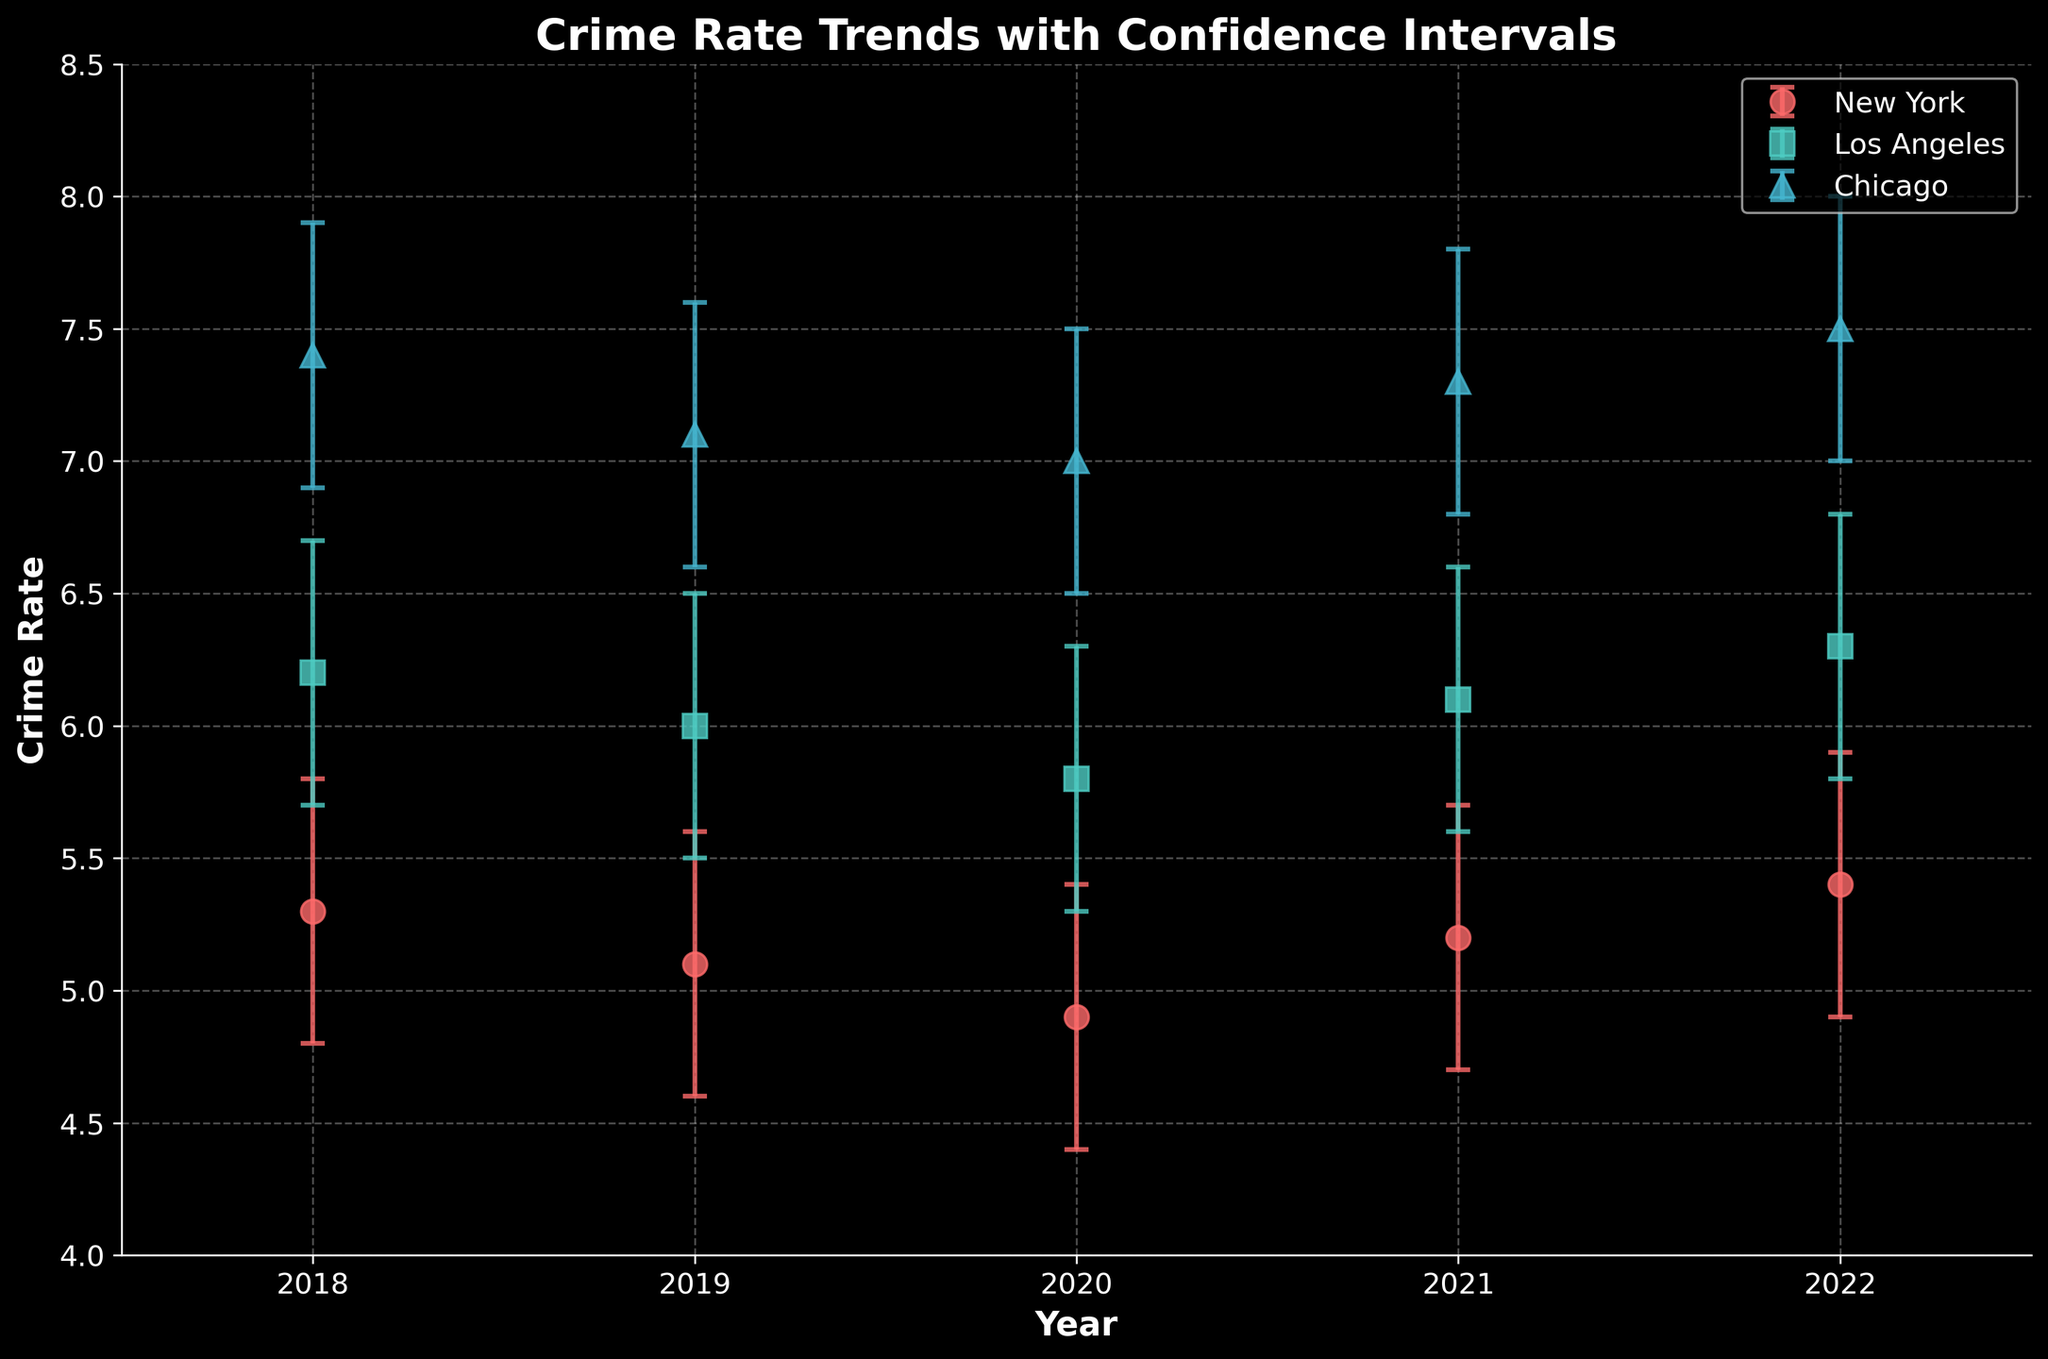what is the title of the figure? The title is prominently displayed at the top of the figure. It helps viewers understand the overall subject being addressed in the plot.
Answer: Crime Rate Trends with Confidence Intervals Which City had the highest crime rate in 2018? By examining the 2018 data points and comparing the crime rates represented by the markers in the plot, the highest value can be determined.
Answer: Chicago How does the crime rate trend in New York from 2018 to 2022? To answer this, visually follow the data points representing New York across the years from 2018 to 2022. Compare the direction and changes in their positions on the y-axis which represents the crime rate.
Answer: The crime rate slightly decreased up to 2020, then increased again by 2022 Which city showed the greatest variation in crime rates across the years? To find this, observe the changes in crime rates (y-values) for each city across the years. The city with the widest range of fluctuations has the greatest variation.
Answer: Chicago What is the average crime rate in Los Angeles over the 5 years shown? Add the crime rates of Los Angeles from 2018 to 2022 and then divide by the number of years (5). The calculation involves summing up all crime rates and calculating the mean. Calculation: (6.2 + 6.0 + 5.8 + 6.1 + 6.3) / 5
Answer: 6.08 In which year did New York show the lowest crime rate? By examining the data points representing New York across the years, it is apparent which year has the marker at the lowest position on the y-axis.
Answer: 2020 What are the axis labels in the figure? The axis labels provide information about what each axis represents, and they are found alongside each axis of the plot.
Answer: Year (x-axis) and Crime Rate (y-axis) Compare the average crime rate between New York and Chicago across the years shown. Which city had a higher average crime rate? First, calculate the average crime rate for both cities over the years. For New York, average is (5.3 + 5.1 + 4.9 + 5.2 + 5.4) / 5, and for Chicago, average is (7.4 + 7.1 + 7.0 + 7.3 + 7.5) / 5. Compare the two resulting values to identify which is higher.
Answer: Chicago Which city shows the most consistent trend in crime rates over the years with minimal fluctuations? To determine this, observe the crime rate trends for each city. The city with data points closely clustered together over the years indicates minimal fluctuations.
Answer: Los Angeles In 2022, compare the confidence intervals of New York and Chicago. Which has the wider interval? Look at the length of the error bars for both New York and Chicago in 2022. The city with the longer error bars represents a wider confidence interval.
Answer: Chicago 